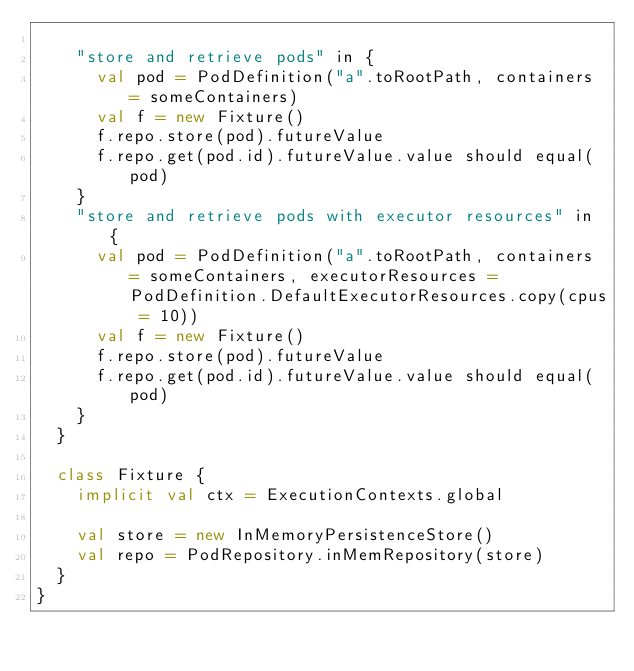Convert code to text. <code><loc_0><loc_0><loc_500><loc_500><_Scala_>
    "store and retrieve pods" in {
      val pod = PodDefinition("a".toRootPath, containers = someContainers)
      val f = new Fixture()
      f.repo.store(pod).futureValue
      f.repo.get(pod.id).futureValue.value should equal(pod)
    }
    "store and retrieve pods with executor resources" in {
      val pod = PodDefinition("a".toRootPath, containers = someContainers, executorResources = PodDefinition.DefaultExecutorResources.copy(cpus = 10))
      val f = new Fixture()
      f.repo.store(pod).futureValue
      f.repo.get(pod.id).futureValue.value should equal(pod)
    }
  }

  class Fixture {
    implicit val ctx = ExecutionContexts.global

    val store = new InMemoryPersistenceStore()
    val repo = PodRepository.inMemRepository(store)
  }
}
</code> 